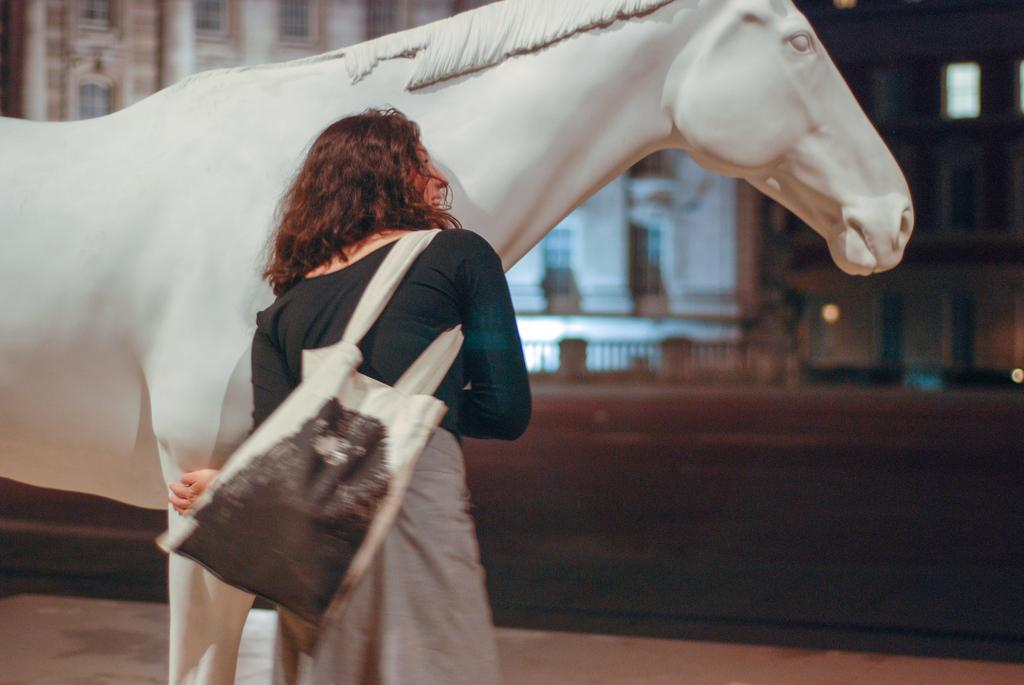Who is present in the image? There is a woman in the image. What is the woman carrying on her shoulder? The woman is wearing a bag on her shoulder. What animal can be seen in the image? There is a horse in the image. What type of structure is visible in the background? There is a building in the background of the image. What color is the friend's shirt in the image? There is no friend present in the image, and therefore no shirt to describe. 